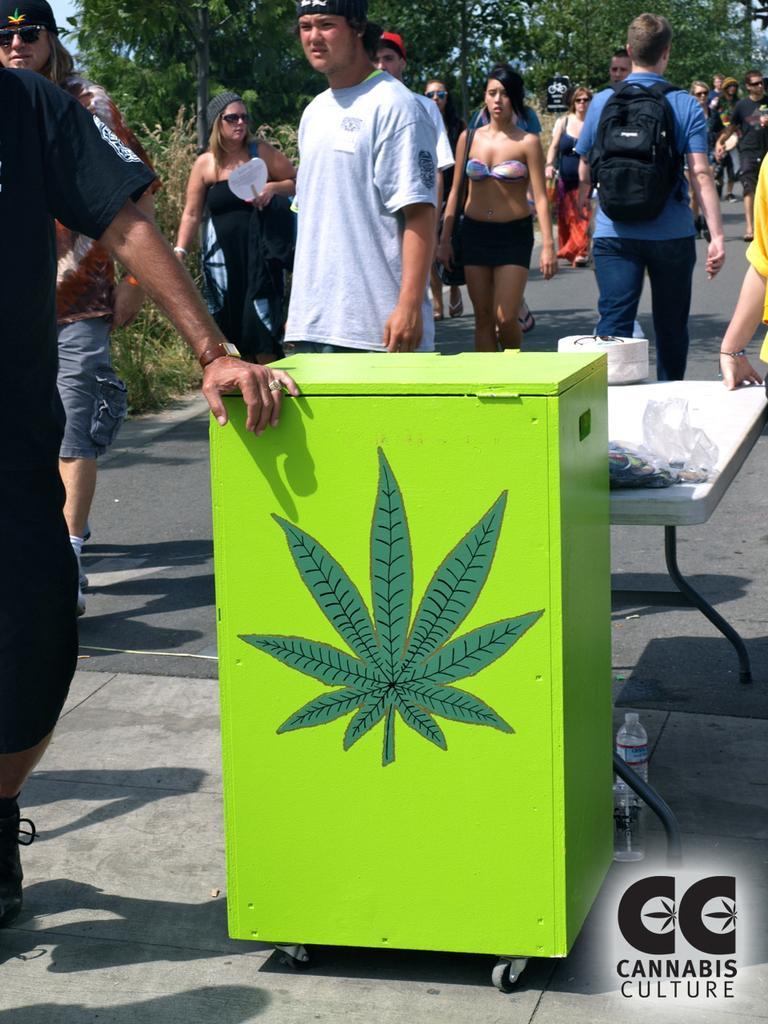Describe this image in one or two sentences. In the center of the image we can see a green color object with wheels on the road. Behind the object we can see a table. We can also see many people walking on the road. Image also consists of trees. In the bottom right corner there is logo. 